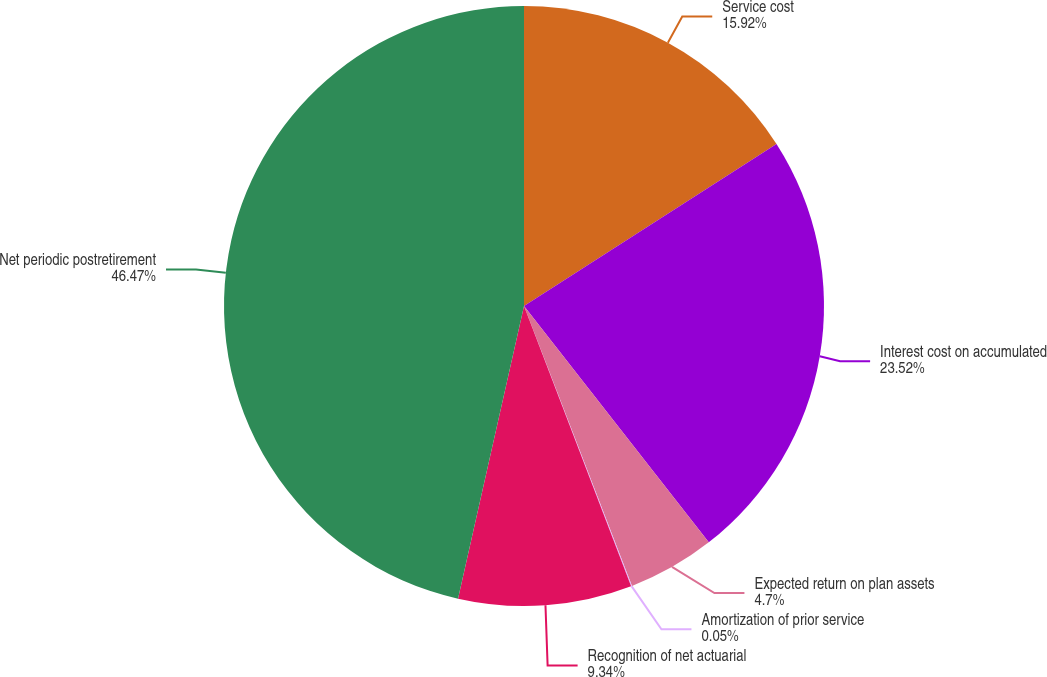<chart> <loc_0><loc_0><loc_500><loc_500><pie_chart><fcel>Service cost<fcel>Interest cost on accumulated<fcel>Expected return on plan assets<fcel>Amortization of prior service<fcel>Recognition of net actuarial<fcel>Net periodic postretirement<nl><fcel>15.92%<fcel>23.52%<fcel>4.7%<fcel>0.05%<fcel>9.34%<fcel>46.47%<nl></chart> 